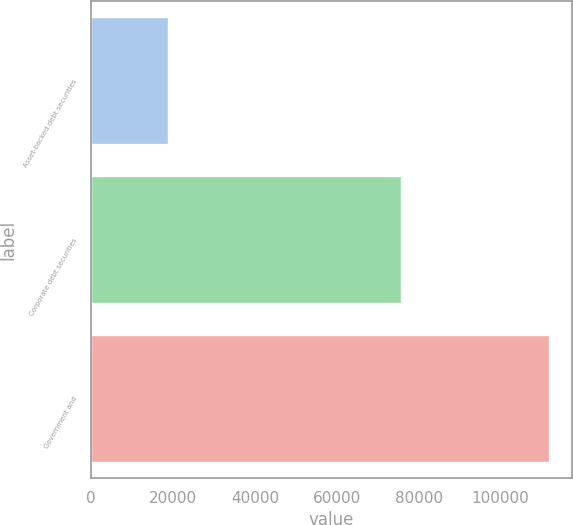<chart> <loc_0><loc_0><loc_500><loc_500><bar_chart><fcel>Asset-backed debt securities<fcel>Corporate debt securities<fcel>Government and<nl><fcel>18823<fcel>75692<fcel>111865<nl></chart> 